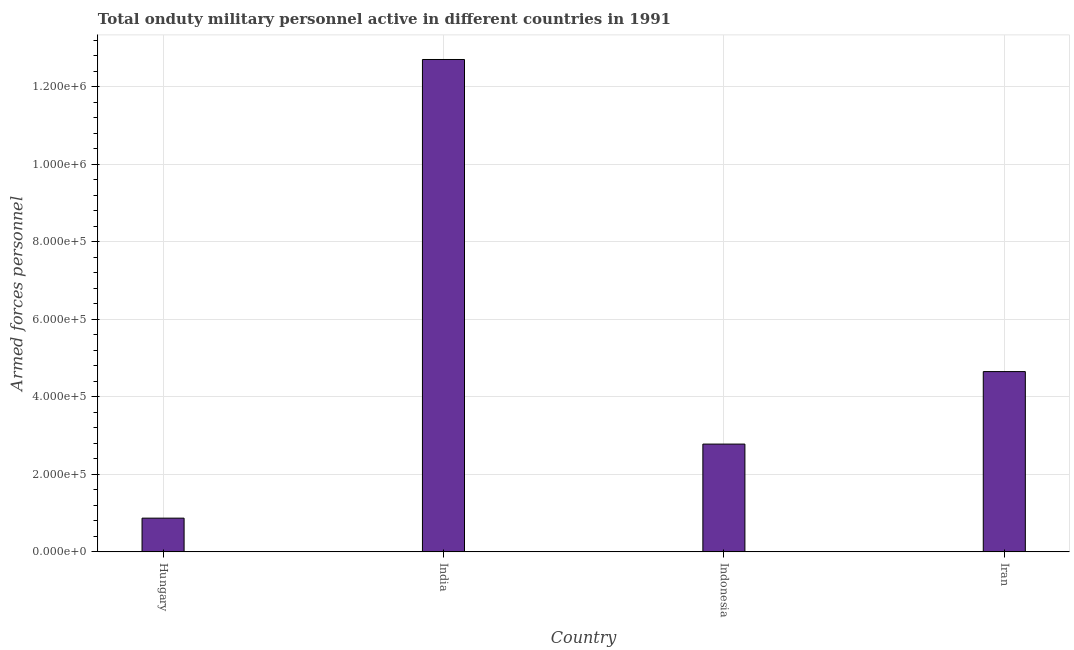Does the graph contain grids?
Offer a terse response. Yes. What is the title of the graph?
Your response must be concise. Total onduty military personnel active in different countries in 1991. What is the label or title of the X-axis?
Offer a very short reply. Country. What is the label or title of the Y-axis?
Provide a succinct answer. Armed forces personnel. What is the number of armed forces personnel in Hungary?
Offer a very short reply. 8.70e+04. Across all countries, what is the maximum number of armed forces personnel?
Give a very brief answer. 1.27e+06. Across all countries, what is the minimum number of armed forces personnel?
Make the answer very short. 8.70e+04. In which country was the number of armed forces personnel maximum?
Offer a very short reply. India. In which country was the number of armed forces personnel minimum?
Make the answer very short. Hungary. What is the sum of the number of armed forces personnel?
Offer a terse response. 2.10e+06. What is the difference between the number of armed forces personnel in Hungary and India?
Give a very brief answer. -1.18e+06. What is the average number of armed forces personnel per country?
Keep it short and to the point. 5.25e+05. What is the median number of armed forces personnel?
Offer a terse response. 3.72e+05. In how many countries, is the number of armed forces personnel greater than 880000 ?
Your answer should be compact. 1. What is the ratio of the number of armed forces personnel in Hungary to that in Iran?
Make the answer very short. 0.19. Is the number of armed forces personnel in Hungary less than that in Iran?
Ensure brevity in your answer.  Yes. Is the difference between the number of armed forces personnel in Hungary and Indonesia greater than the difference between any two countries?
Give a very brief answer. No. What is the difference between the highest and the second highest number of armed forces personnel?
Offer a terse response. 8.05e+05. Is the sum of the number of armed forces personnel in Hungary and Indonesia greater than the maximum number of armed forces personnel across all countries?
Your response must be concise. No. What is the difference between the highest and the lowest number of armed forces personnel?
Offer a terse response. 1.18e+06. What is the Armed forces personnel of Hungary?
Your answer should be very brief. 8.70e+04. What is the Armed forces personnel in India?
Offer a very short reply. 1.27e+06. What is the Armed forces personnel of Indonesia?
Provide a short and direct response. 2.78e+05. What is the Armed forces personnel in Iran?
Offer a terse response. 4.65e+05. What is the difference between the Armed forces personnel in Hungary and India?
Make the answer very short. -1.18e+06. What is the difference between the Armed forces personnel in Hungary and Indonesia?
Provide a succinct answer. -1.91e+05. What is the difference between the Armed forces personnel in Hungary and Iran?
Ensure brevity in your answer.  -3.78e+05. What is the difference between the Armed forces personnel in India and Indonesia?
Make the answer very short. 9.92e+05. What is the difference between the Armed forces personnel in India and Iran?
Your answer should be very brief. 8.05e+05. What is the difference between the Armed forces personnel in Indonesia and Iran?
Your answer should be very brief. -1.87e+05. What is the ratio of the Armed forces personnel in Hungary to that in India?
Offer a terse response. 0.07. What is the ratio of the Armed forces personnel in Hungary to that in Indonesia?
Provide a short and direct response. 0.31. What is the ratio of the Armed forces personnel in Hungary to that in Iran?
Your answer should be compact. 0.19. What is the ratio of the Armed forces personnel in India to that in Indonesia?
Offer a very short reply. 4.57. What is the ratio of the Armed forces personnel in India to that in Iran?
Provide a succinct answer. 2.73. What is the ratio of the Armed forces personnel in Indonesia to that in Iran?
Provide a succinct answer. 0.6. 